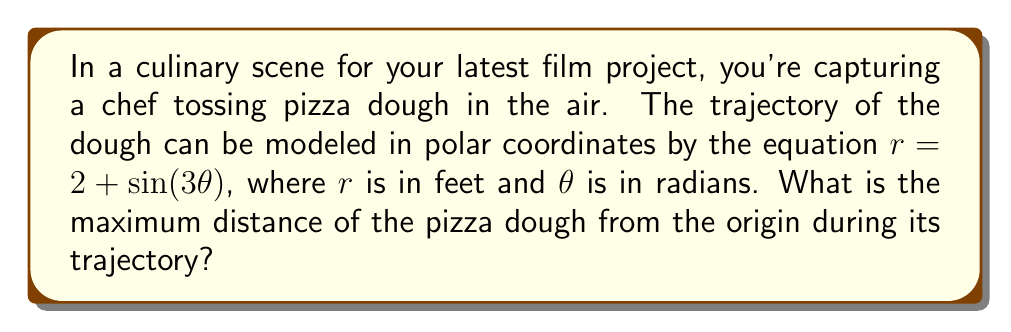Show me your answer to this math problem. To find the maximum distance of the pizza dough from the origin, we need to determine the maximum value of $r$ in the given equation.

1) The equation of the trajectory is:
   $r = 2 + \sin(3\theta)$

2) The maximum value of $r$ will occur when $\sin(3\theta)$ is at its maximum.

3) We know that the maximum value of sine is 1, which occurs when its argument is $\frac{\pi}{2}$ (or odd multiples of it).

4) So, the maximum value of $r$ will be:
   $r_{max} = 2 + 1 = 3$

5) This means that the pizza dough will reach a maximum distance of 3 feet from the origin during its trajectory.

[asy]
import graph;
size(200);
real r(real t) {return 2+sin(3t);}
draw(polargraph(r,0,2pi,operator ..),blue);
dot((3,0),red);
label("$r_{max}$",(1.5,0),E);
[/asy]

The polar plot above illustrates the trajectory, with the red dot indicating the maximum distance from the origin.
Answer: The maximum distance of the pizza dough from the origin is 3 feet. 